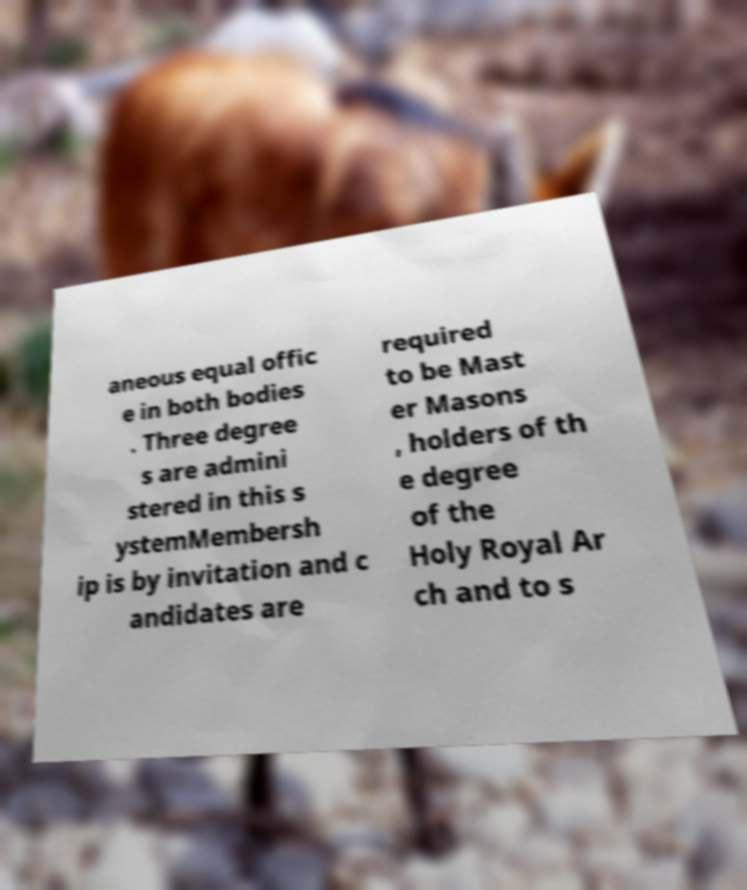Can you accurately transcribe the text from the provided image for me? aneous equal offic e in both bodies . Three degree s are admini stered in this s ystemMembersh ip is by invitation and c andidates are required to be Mast er Masons , holders of th e degree of the Holy Royal Ar ch and to s 